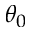<formula> <loc_0><loc_0><loc_500><loc_500>\theta _ { 0 }</formula> 